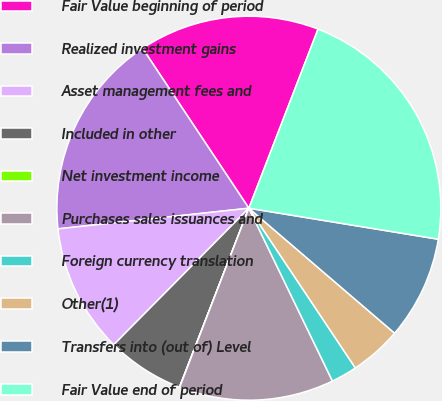Convert chart. <chart><loc_0><loc_0><loc_500><loc_500><pie_chart><fcel>Fair Value beginning of period<fcel>Realized investment gains<fcel>Asset management fees and<fcel>Included in other<fcel>Net investment income<fcel>Purchases sales issuances and<fcel>Foreign currency translation<fcel>Other(1)<fcel>Transfers into (out of) Level<fcel>Fair Value end of period<nl><fcel>15.21%<fcel>17.38%<fcel>10.87%<fcel>6.53%<fcel>0.02%<fcel>13.04%<fcel>2.19%<fcel>4.36%<fcel>8.7%<fcel>21.72%<nl></chart> 